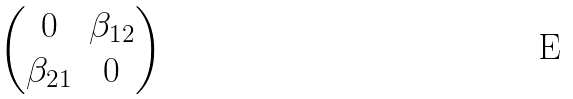<formula> <loc_0><loc_0><loc_500><loc_500>\begin{pmatrix} 0 & \beta _ { 1 2 } \\ \beta _ { 2 1 } & 0 \end{pmatrix}</formula> 